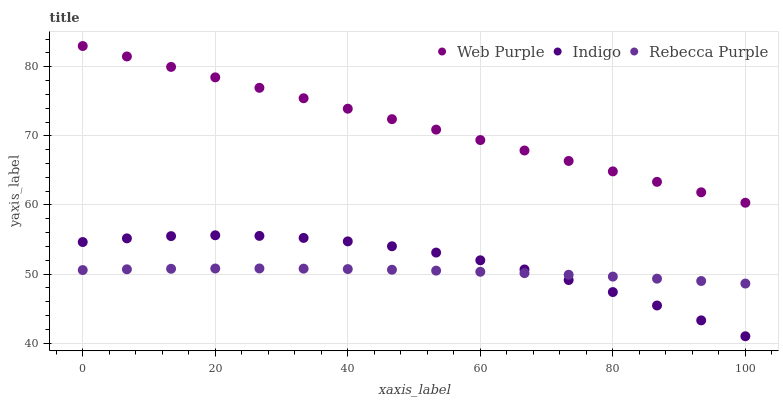Does Rebecca Purple have the minimum area under the curve?
Answer yes or no. Yes. Does Web Purple have the maximum area under the curve?
Answer yes or no. Yes. Does Indigo have the minimum area under the curve?
Answer yes or no. No. Does Indigo have the maximum area under the curve?
Answer yes or no. No. Is Web Purple the smoothest?
Answer yes or no. Yes. Is Indigo the roughest?
Answer yes or no. Yes. Is Rebecca Purple the smoothest?
Answer yes or no. No. Is Rebecca Purple the roughest?
Answer yes or no. No. Does Indigo have the lowest value?
Answer yes or no. Yes. Does Rebecca Purple have the lowest value?
Answer yes or no. No. Does Web Purple have the highest value?
Answer yes or no. Yes. Does Indigo have the highest value?
Answer yes or no. No. Is Rebecca Purple less than Web Purple?
Answer yes or no. Yes. Is Web Purple greater than Rebecca Purple?
Answer yes or no. Yes. Does Indigo intersect Rebecca Purple?
Answer yes or no. Yes. Is Indigo less than Rebecca Purple?
Answer yes or no. No. Is Indigo greater than Rebecca Purple?
Answer yes or no. No. Does Rebecca Purple intersect Web Purple?
Answer yes or no. No. 